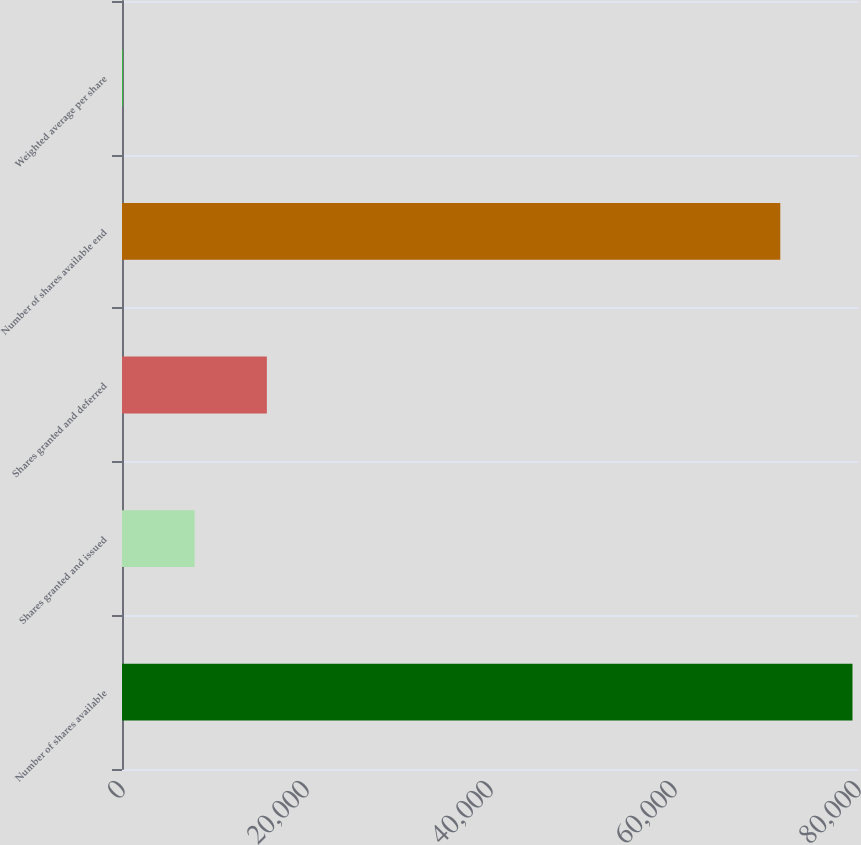<chart> <loc_0><loc_0><loc_500><loc_500><bar_chart><fcel>Number of shares available<fcel>Shares granted and issued<fcel>Shares granted and deferred<fcel>Number of shares available end<fcel>Weighted average per share<nl><fcel>79399.9<fcel>7898.63<fcel>15745.6<fcel>71553<fcel>51.7<nl></chart> 